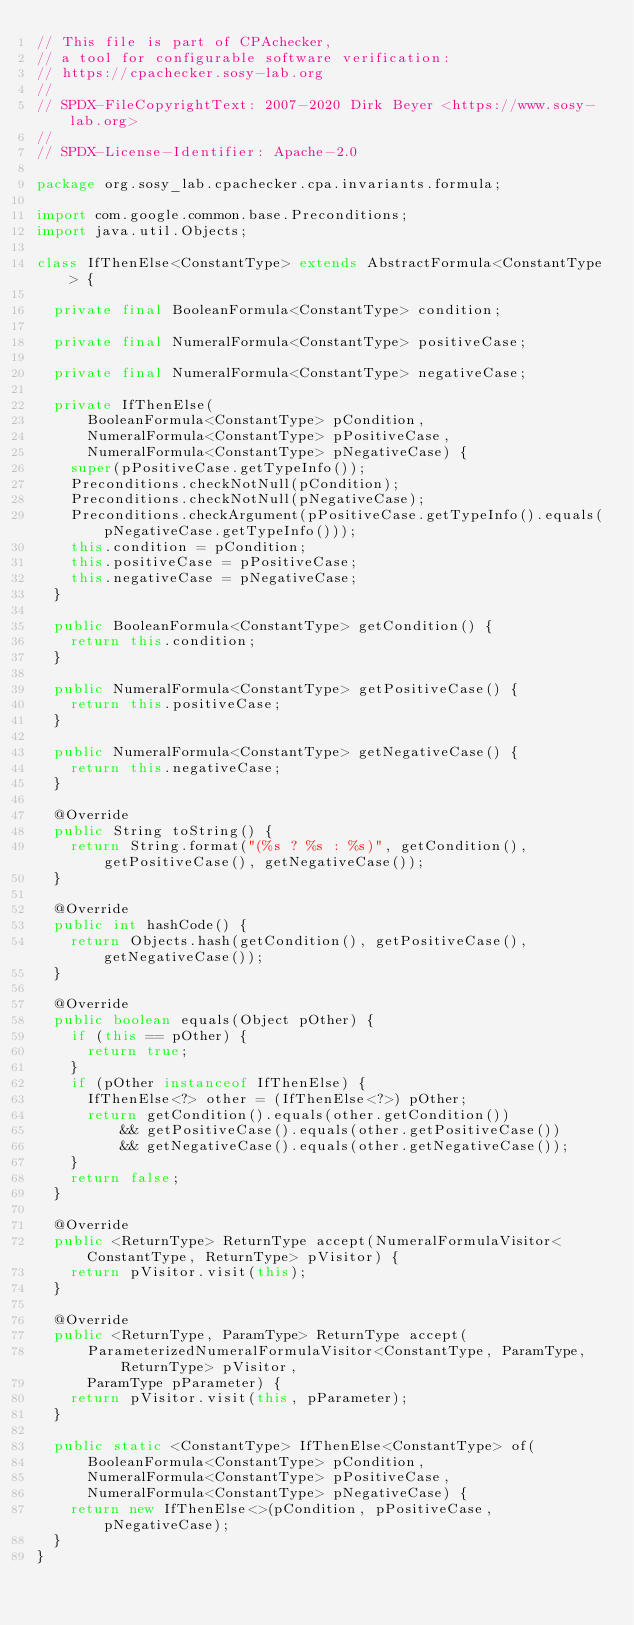<code> <loc_0><loc_0><loc_500><loc_500><_Java_>// This file is part of CPAchecker,
// a tool for configurable software verification:
// https://cpachecker.sosy-lab.org
//
// SPDX-FileCopyrightText: 2007-2020 Dirk Beyer <https://www.sosy-lab.org>
//
// SPDX-License-Identifier: Apache-2.0

package org.sosy_lab.cpachecker.cpa.invariants.formula;

import com.google.common.base.Preconditions;
import java.util.Objects;

class IfThenElse<ConstantType> extends AbstractFormula<ConstantType> {

  private final BooleanFormula<ConstantType> condition;

  private final NumeralFormula<ConstantType> positiveCase;

  private final NumeralFormula<ConstantType> negativeCase;

  private IfThenElse(
      BooleanFormula<ConstantType> pCondition,
      NumeralFormula<ConstantType> pPositiveCase,
      NumeralFormula<ConstantType> pNegativeCase) {
    super(pPositiveCase.getTypeInfo());
    Preconditions.checkNotNull(pCondition);
    Preconditions.checkNotNull(pNegativeCase);
    Preconditions.checkArgument(pPositiveCase.getTypeInfo().equals(pNegativeCase.getTypeInfo()));
    this.condition = pCondition;
    this.positiveCase = pPositiveCase;
    this.negativeCase = pNegativeCase;
  }

  public BooleanFormula<ConstantType> getCondition() {
    return this.condition;
  }

  public NumeralFormula<ConstantType> getPositiveCase() {
    return this.positiveCase;
  }

  public NumeralFormula<ConstantType> getNegativeCase() {
    return this.negativeCase;
  }

  @Override
  public String toString() {
    return String.format("(%s ? %s : %s)", getCondition(), getPositiveCase(), getNegativeCase());
  }

  @Override
  public int hashCode() {
    return Objects.hash(getCondition(), getPositiveCase(), getNegativeCase());
  }

  @Override
  public boolean equals(Object pOther) {
    if (this == pOther) {
      return true;
    }
    if (pOther instanceof IfThenElse) {
      IfThenElse<?> other = (IfThenElse<?>) pOther;
      return getCondition().equals(other.getCondition())
          && getPositiveCase().equals(other.getPositiveCase())
          && getNegativeCase().equals(other.getNegativeCase());
    }
    return false;
  }

  @Override
  public <ReturnType> ReturnType accept(NumeralFormulaVisitor<ConstantType, ReturnType> pVisitor) {
    return pVisitor.visit(this);
  }

  @Override
  public <ReturnType, ParamType> ReturnType accept(
      ParameterizedNumeralFormulaVisitor<ConstantType, ParamType, ReturnType> pVisitor,
      ParamType pParameter) {
    return pVisitor.visit(this, pParameter);
  }

  public static <ConstantType> IfThenElse<ConstantType> of(
      BooleanFormula<ConstantType> pCondition,
      NumeralFormula<ConstantType> pPositiveCase,
      NumeralFormula<ConstantType> pNegativeCase) {
    return new IfThenElse<>(pCondition, pPositiveCase, pNegativeCase);
  }
}
</code> 